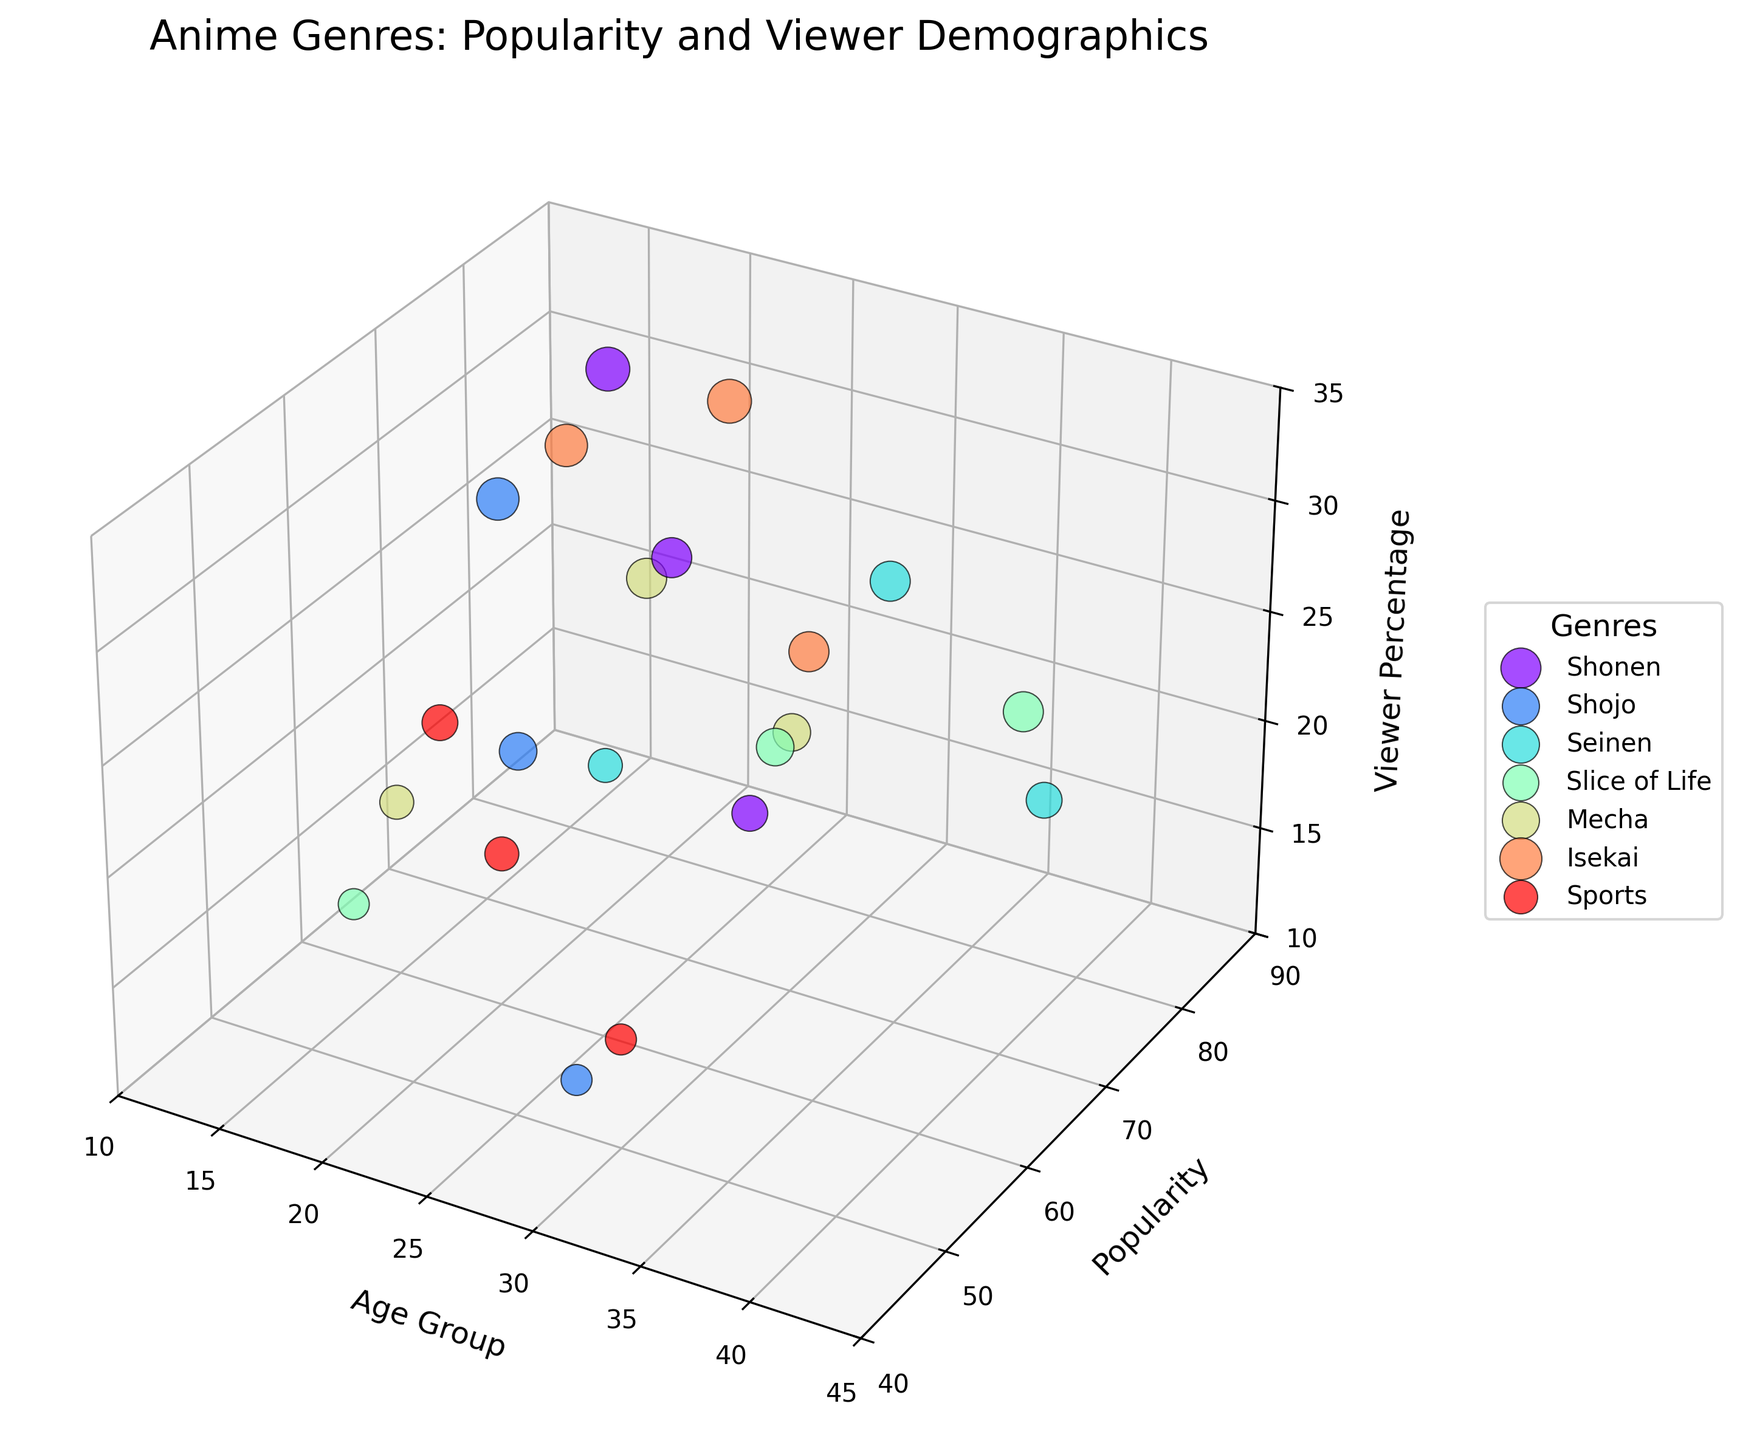What is the title of the chart? The title is usually prominently displayed at the top of the chart. In this figure, the title is "Anime Genres: Popularity and Viewer Demographics".
Answer: Anime Genres: Popularity and Viewer Demographics Which axis represents age groups? The chart typically has three axes for different dimensions. The x-axis of this 3D bubble chart represents the age groups, with labels such as '13-17', '18-24', '25-34', and '35-44'.
Answer: x-axis Which genre has the highest popularity among the 13-17 age group? Look for the bubbles representing the 13-17 age group and compare their heights along the y-axis. The bubble with the highest value (closest to 90) indicates the most popular genre. In this case, it's Shonen with a popularity of 85.
Answer: Shonen What is the average viewer percentage of Shonen across all age groups? To find the average, sum the viewer percentages for each age group under Shonen (30 + 25 + 20) and divide by the number of age groups (3).
Answer: 25 Between Seinen and Slice of Life, which genre has a higher viewer percentage in the 25-34 age group? Locate the bubbles for Seinen and Slice of Life in the 25-34 age group and compare their positions along the z-axis. Seinen has a viewer percentage of 25, while Slice of Life has 22.
Answer: Seinen Do any genres have a viewer percentage of 30%? Look for any bubbles that are exactly at the level representing 30% on the z-axis. Both Shonen and Isekai in the 13-17 age group have viewer percentages of 30%.
Answer: Shonen, Isekai What is the difference in popularity between Shojo and Mecha in the 18-24 age group? Find the popularity values for Shojo and Mecha in the 18-24 age group along the y-axis. Subtract the value for Shojo (60) from the value for Mecha (75).
Answer: 15 Which age group has the highest viewer percentage for Slice of Life? Locate the bubbles for Slice of Life and find the one highest on the z-axis. This value represents the 35-44 age group with a viewer percentage of 25%.
Answer: 35-44 How many data points are there in total for the genre Seinen? Count the number of bubbles/color points corresponding to the Seinen genre in the chart. There are three age groups represented for Seinen.
Answer: 3 Which genres have more viewer percentage among the 18-24 age group than in the 25-34 age group? Compare the z-axis values for the genres in the 18-24 and 25-34 age groups. Isekai, Mecha, and Seinen have higher viewer percentages in the 18-24 compared to 25-34.
Answer: Isekai, Mecha, Seinen 